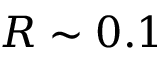<formula> <loc_0><loc_0><loc_500><loc_500>R \sim 0 . 1</formula> 